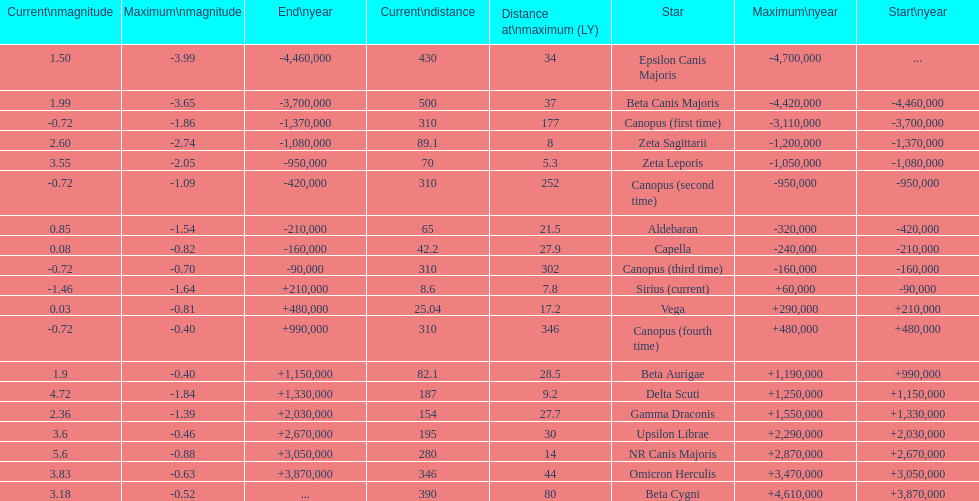How many stars have a distance at maximum of 30 light years or higher? 9. Parse the full table. {'header': ['Current\\nmagnitude', 'Maximum\\nmagnitude', 'End\\nyear', 'Current\\ndistance', 'Distance at\\nmaximum (LY)', 'Star', 'Maximum\\nyear', 'Start\\nyear'], 'rows': [['1.50', '-3.99', '-4,460,000', '430', '34', 'Epsilon Canis Majoris', '-4,700,000', '...'], ['1.99', '-3.65', '-3,700,000', '500', '37', 'Beta Canis Majoris', '-4,420,000', '-4,460,000'], ['-0.72', '-1.86', '-1,370,000', '310', '177', 'Canopus (first time)', '-3,110,000', '-3,700,000'], ['2.60', '-2.74', '-1,080,000', '89.1', '8', 'Zeta Sagittarii', '-1,200,000', '-1,370,000'], ['3.55', '-2.05', '-950,000', '70', '5.3', 'Zeta Leporis', '-1,050,000', '-1,080,000'], ['-0.72', '-1.09', '-420,000', '310', '252', 'Canopus (second time)', '-950,000', '-950,000'], ['0.85', '-1.54', '-210,000', '65', '21.5', 'Aldebaran', '-320,000', '-420,000'], ['0.08', '-0.82', '-160,000', '42.2', '27.9', 'Capella', '-240,000', '-210,000'], ['-0.72', '-0.70', '-90,000', '310', '302', 'Canopus (third time)', '-160,000', '-160,000'], ['-1.46', '-1.64', '+210,000', '8.6', '7.8', 'Sirius (current)', '+60,000', '-90,000'], ['0.03', '-0.81', '+480,000', '25.04', '17.2', 'Vega', '+290,000', '+210,000'], ['-0.72', '-0.40', '+990,000', '310', '346', 'Canopus (fourth time)', '+480,000', '+480,000'], ['1.9', '-0.40', '+1,150,000', '82.1', '28.5', 'Beta Aurigae', '+1,190,000', '+990,000'], ['4.72', '-1.84', '+1,330,000', '187', '9.2', 'Delta Scuti', '+1,250,000', '+1,150,000'], ['2.36', '-1.39', '+2,030,000', '154', '27.7', 'Gamma Draconis', '+1,550,000', '+1,330,000'], ['3.6', '-0.46', '+2,670,000', '195', '30', 'Upsilon Librae', '+2,290,000', '+2,030,000'], ['5.6', '-0.88', '+3,050,000', '280', '14', 'NR Canis Majoris', '+2,870,000', '+2,670,000'], ['3.83', '-0.63', '+3,870,000', '346', '44', 'Omicron Herculis', '+3,470,000', '+3,050,000'], ['3.18', '-0.52', '...', '390', '80', 'Beta Cygni', '+4,610,000', '+3,870,000']]} 